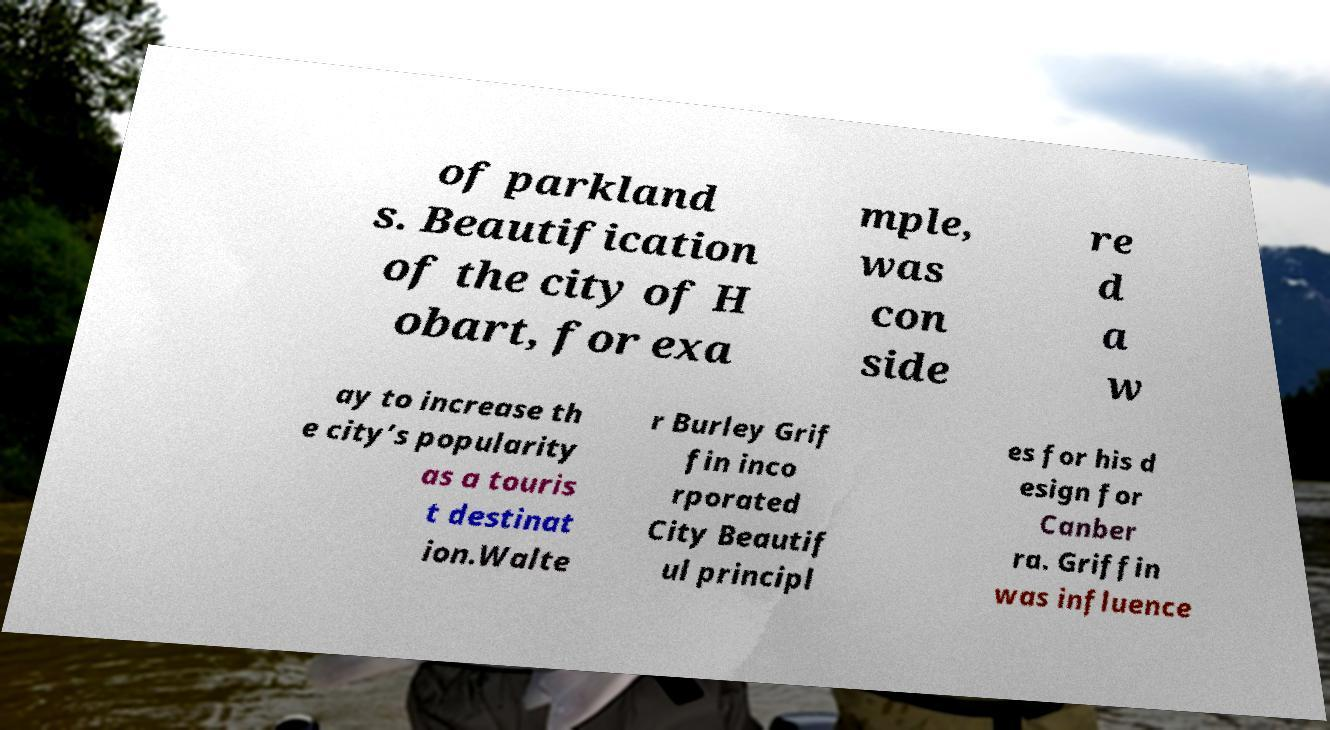What messages or text are displayed in this image? I need them in a readable, typed format. of parkland s. Beautification of the city of H obart, for exa mple, was con side re d a w ay to increase th e city’s popularity as a touris t destinat ion.Walte r Burley Grif fin inco rporated City Beautif ul principl es for his d esign for Canber ra. Griffin was influence 